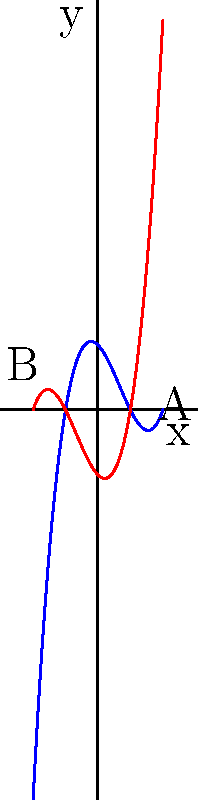As a photojournalist documenting mathematical research, you've captured an image of two polynomial graphs. The blue curve represents $f(x) = x^3 - 2x^2 - x + 2$, and the red curve represents $g(x) = x^3 + 2x^2 - x - 2$. How does changing the sign of the $x^2$ term coefficient affect the overall shape of the graph, particularly in the regions labeled A and B? To understand the effect of changing the sign of the $x^2$ term coefficient, let's analyze the graphs step-by-step:

1. The blue curve $f(x) = x^3 - 2x^2 - x + 2$ has a negative $x^2$ term (-2x^2).
2. The red curve $g(x) = x^3 + 2x^2 - x - 2$ has a positive $x^2$ term (+2x^2).
3. Both curves have the same leading term ($x^3$), so they will have similar behavior as $x$ approaches $\pm\infty$.
4. The difference in shape is most noticeable in the middle range of x-values.
5. In region A (positive x-values):
   - The blue curve (negative $x^2$ term) bends downward more sharply.
   - The red curve (positive $x^2$ term) rises more steeply.
6. In region B (negative x-values):
   - The blue curve (negative $x^2$ term) rises more steeply.
   - The red curve (positive $x^2$ term) bends downward more sharply.
7. This difference in behavior is due to the $x^2$ term either reinforcing or opposing the $x^3$ term's direction in different regions.

In summary, changing the sign of the $x^2$ term coefficient from negative to positive causes the curve to rise more steeply for positive x-values and bend more sharply downward for negative x-values.
Answer: Changing the $x^2$ coefficient sign reverses the curve's bending direction in positive and negative x-regions. 